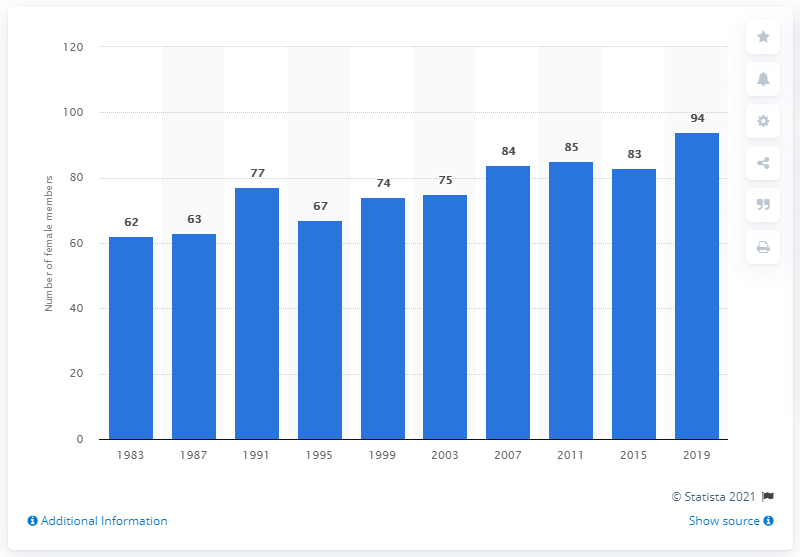Mention a couple of crucial points in this snapshot. In 2019, 94 representatives out of the 200 members of the Parliament of Finland were female. 